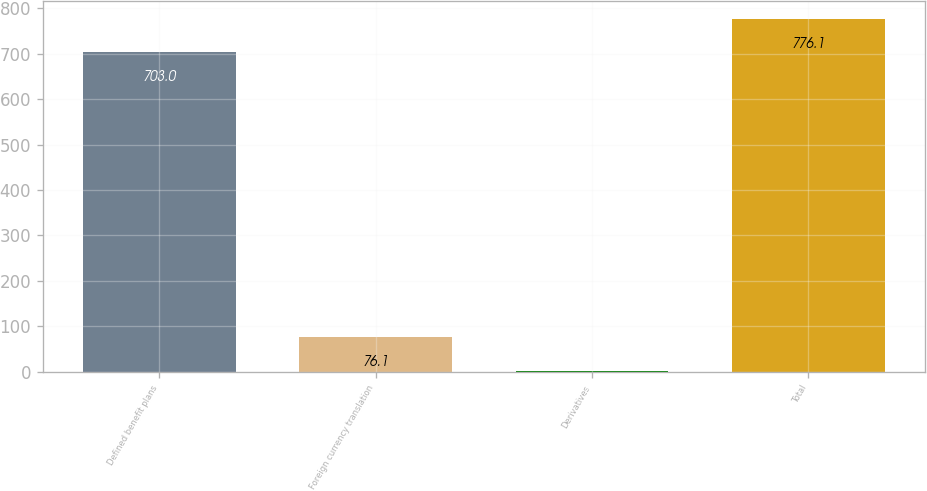<chart> <loc_0><loc_0><loc_500><loc_500><bar_chart><fcel>Defined benefit plans<fcel>Foreign currency translation<fcel>Derivatives<fcel>Total<nl><fcel>703<fcel>76.1<fcel>3<fcel>776.1<nl></chart> 